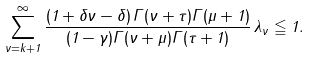<formula> <loc_0><loc_0><loc_500><loc_500>\sum _ { \nu = k + 1 } ^ { \infty } \frac { ( 1 + \delta \nu - \delta ) \, \Gamma ( \nu + \tau ) \Gamma { ( \mu + 1 ) } } { ( 1 - \gamma ) \Gamma ( \nu + \mu ) \Gamma ( \tau + 1 ) } \, \lambda _ { \nu } \leqq 1 .</formula> 